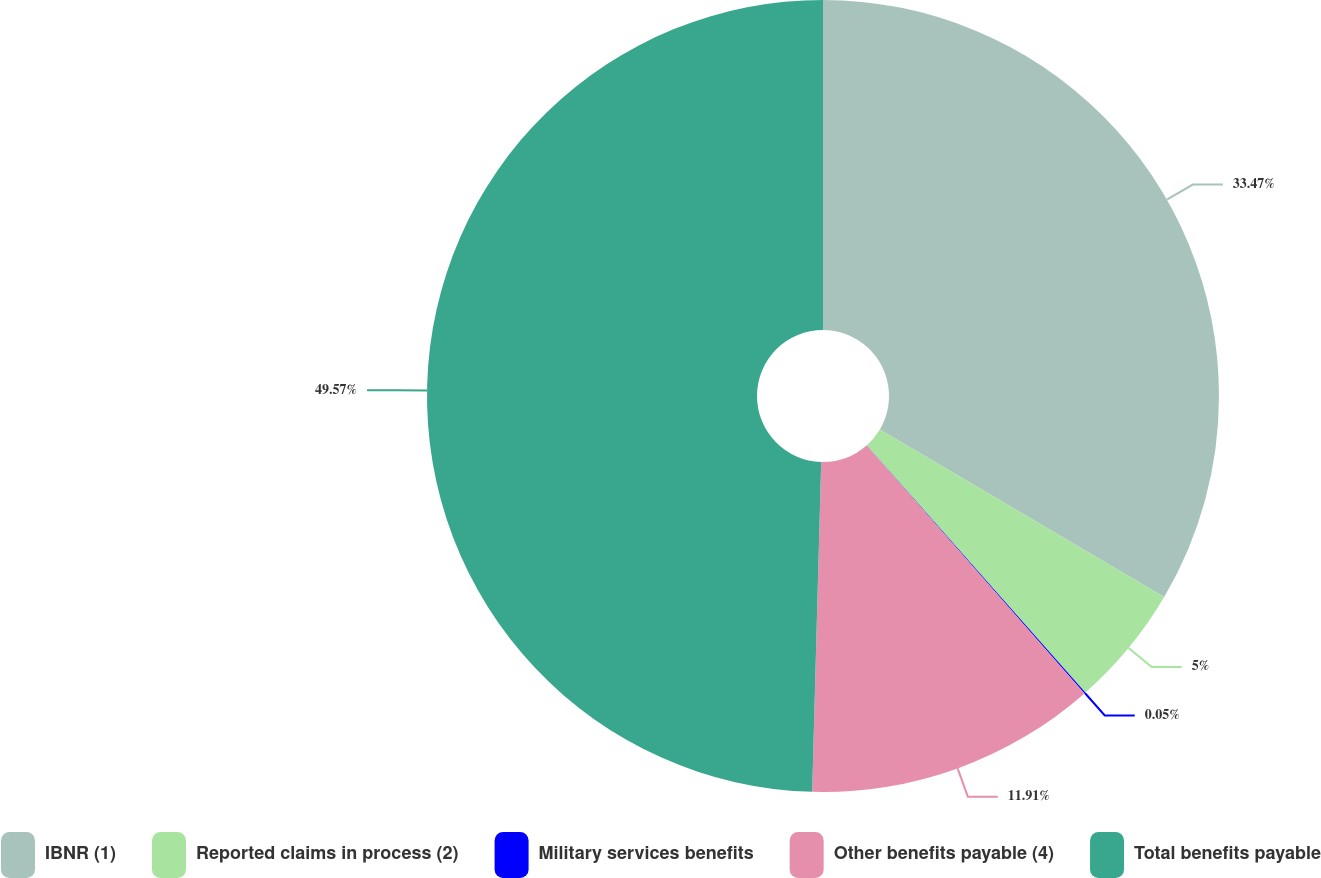<chart> <loc_0><loc_0><loc_500><loc_500><pie_chart><fcel>IBNR (1)<fcel>Reported claims in process (2)<fcel>Military services benefits<fcel>Other benefits payable (4)<fcel>Total benefits payable<nl><fcel>33.47%<fcel>5.0%<fcel>0.05%<fcel>11.91%<fcel>49.56%<nl></chart> 